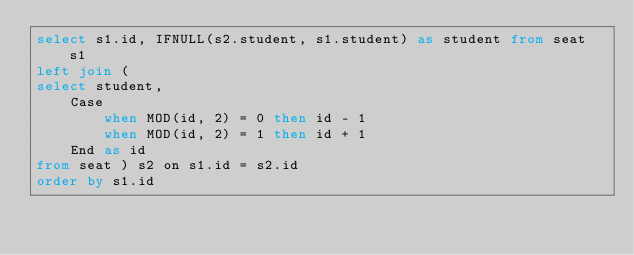Convert code to text. <code><loc_0><loc_0><loc_500><loc_500><_SQL_>select s1.id, IFNULL(s2.student, s1.student) as student from seat s1
left join (
select student, 
    Case 
        when MOD(id, 2) = 0 then id - 1
        when MOD(id, 2) = 1 then id + 1
    End as id
from seat ) s2 on s1.id = s2.id
order by s1.id
</code> 